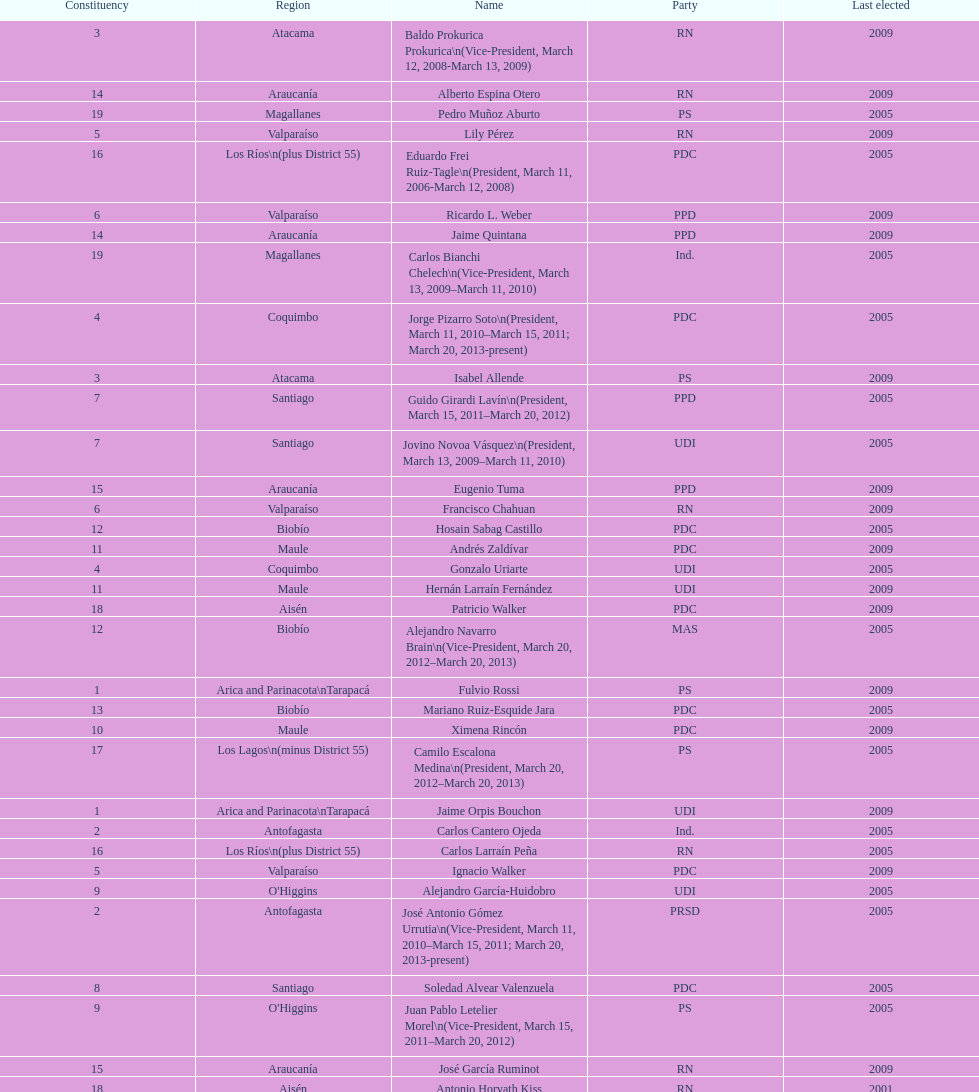Which party did jaime quintana belong to? PPD. 